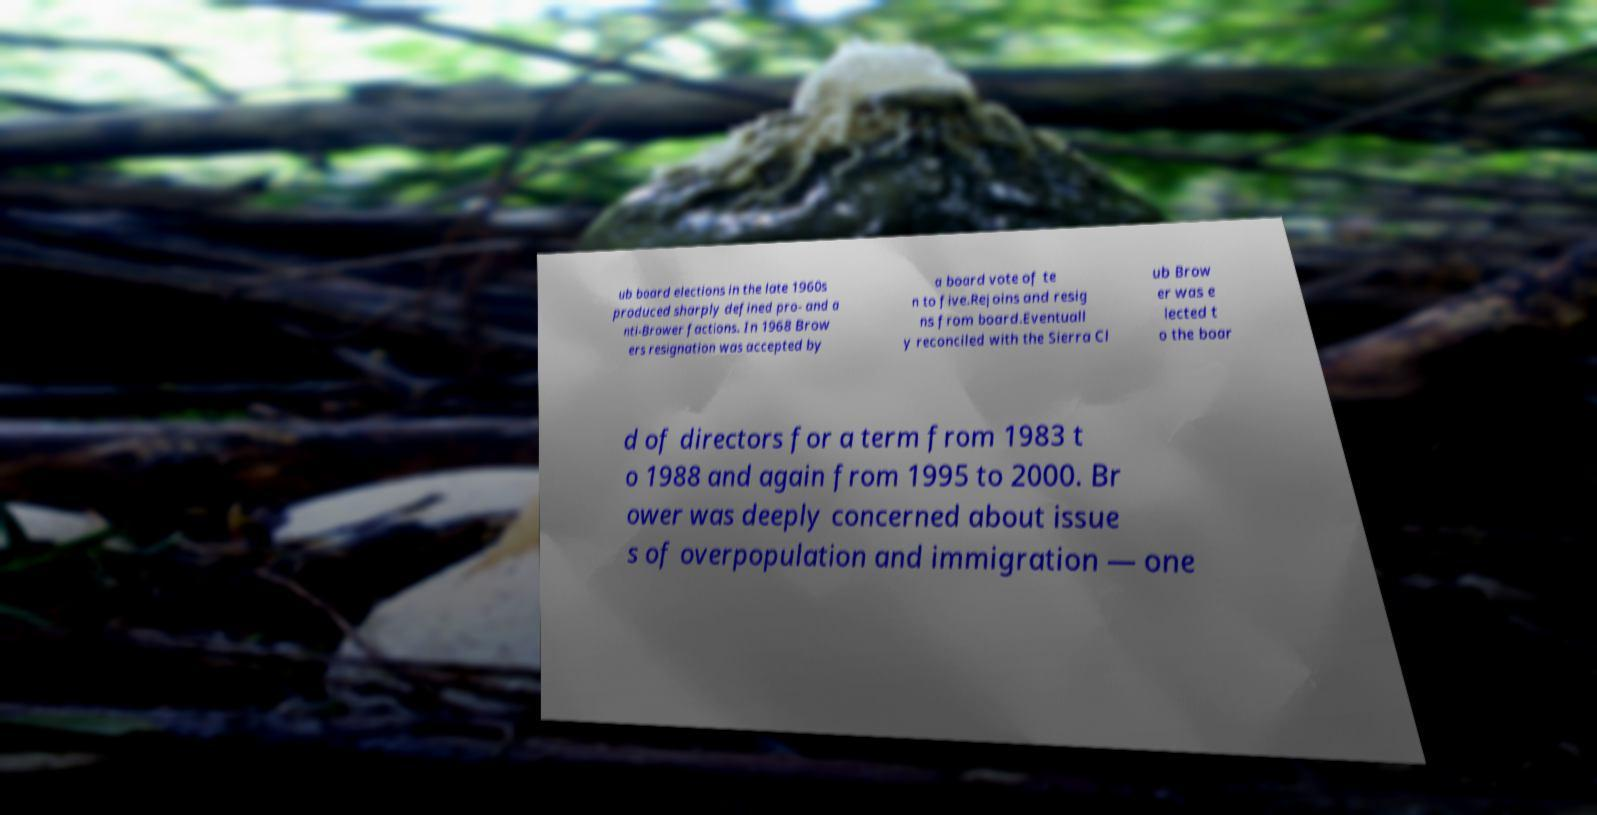Please identify and transcribe the text found in this image. ub board elections in the late 1960s produced sharply defined pro- and a nti-Brower factions. In 1968 Brow ers resignation was accepted by a board vote of te n to five.Rejoins and resig ns from board.Eventuall y reconciled with the Sierra Cl ub Brow er was e lected t o the boar d of directors for a term from 1983 t o 1988 and again from 1995 to 2000. Br ower was deeply concerned about issue s of overpopulation and immigration — one 